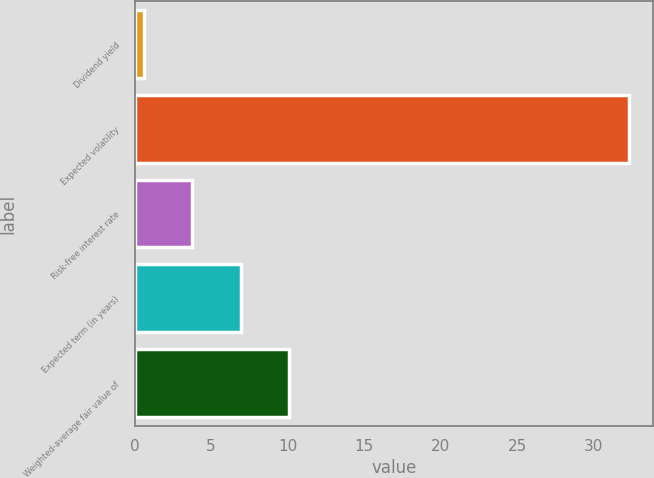Convert chart to OTSL. <chart><loc_0><loc_0><loc_500><loc_500><bar_chart><fcel>Dividend yield<fcel>Expected volatility<fcel>Risk-free interest rate<fcel>Expected term (in years)<fcel>Weighted-average fair value of<nl><fcel>0.6<fcel>32.3<fcel>3.77<fcel>6.94<fcel>10.11<nl></chart> 